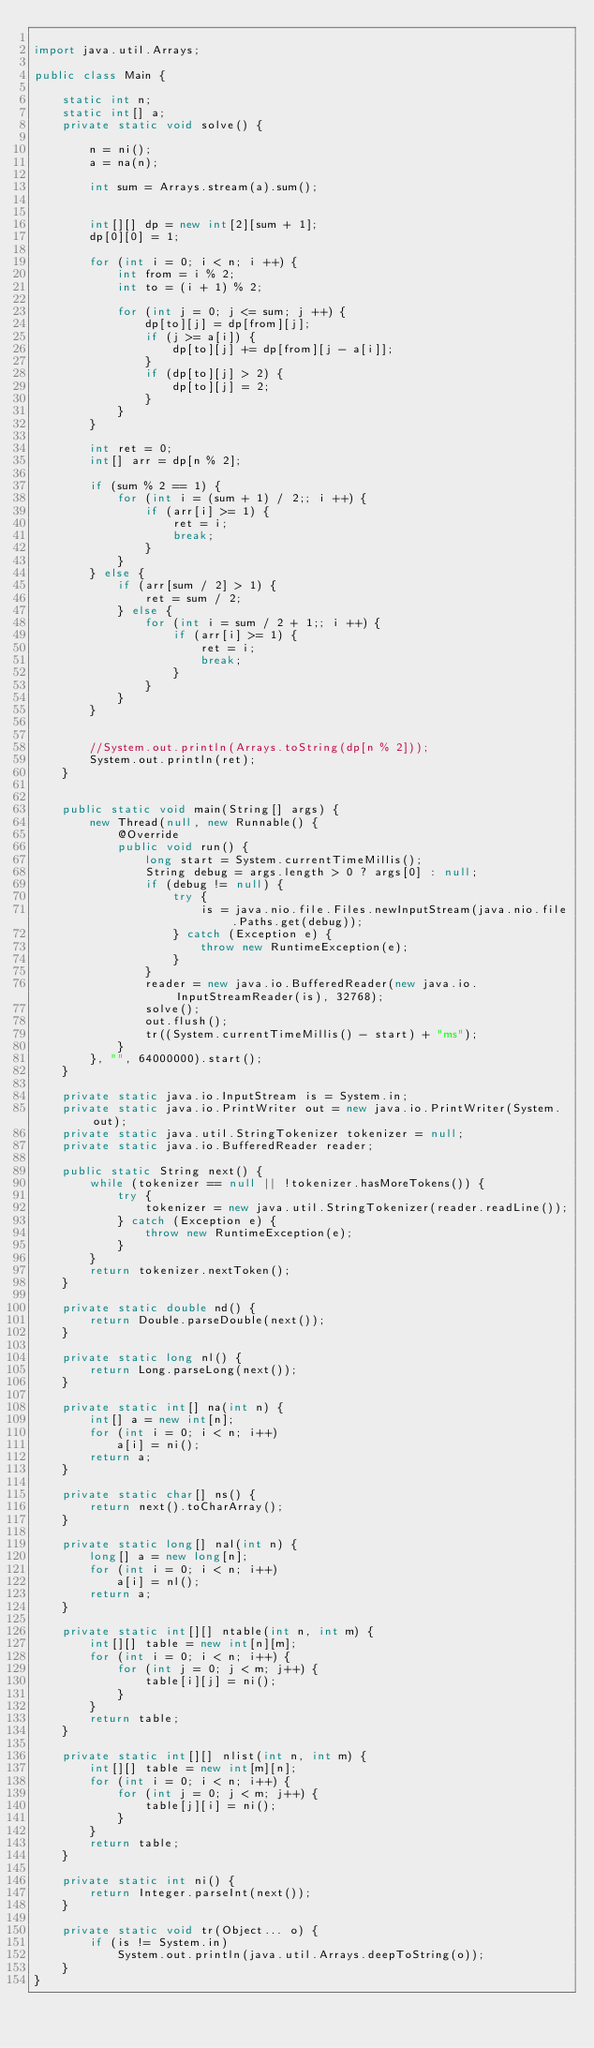Convert code to text. <code><loc_0><loc_0><loc_500><loc_500><_Java_>
import java.util.Arrays;

public class Main {

	static int n;
	static int[] a;
	private static void solve() {
		
		n = ni();
		a = na(n);

		int sum = Arrays.stream(a).sum();


		int[][] dp = new int[2][sum + 1];
		dp[0][0] = 1;

		for (int i = 0; i < n; i ++) {
			int from = i % 2;
			int to = (i + 1) % 2;
			
			for (int j = 0; j <= sum; j ++) {
				dp[to][j] = dp[from][j];
				if (j >= a[i]) {
					dp[to][j] += dp[from][j - a[i]];
				}
				if (dp[to][j] > 2) {
					dp[to][j] = 2;
				}
			}
		}
		
		int ret = 0;
		int[] arr = dp[n % 2];

		if (sum % 2 == 1) {
			for (int i = (sum + 1) / 2;; i ++) {
				if (arr[i] >= 1) {
					ret = i;
					break;
				}
			}
		} else {
			if (arr[sum / 2] > 1) {
				ret = sum / 2;
			} else {
				for (int i = sum / 2 + 1;; i ++) {
					if (arr[i] >= 1) {
						ret = i;
						break;
					}
				}
			}
		}
		
		
		//System.out.println(Arrays.toString(dp[n % 2]));
		System.out.println(ret);
	}
	

	public static void main(String[] args) {
		new Thread(null, new Runnable() {
			@Override
			public void run() {
				long start = System.currentTimeMillis();
				String debug = args.length > 0 ? args[0] : null;
				if (debug != null) {
					try {
						is = java.nio.file.Files.newInputStream(java.nio.file.Paths.get(debug));
					} catch (Exception e) {
						throw new RuntimeException(e);
					}
				}
				reader = new java.io.BufferedReader(new java.io.InputStreamReader(is), 32768);
				solve();
				out.flush();
				tr((System.currentTimeMillis() - start) + "ms");
			}
		}, "", 64000000).start();
	}

	private static java.io.InputStream is = System.in;
	private static java.io.PrintWriter out = new java.io.PrintWriter(System.out);
	private static java.util.StringTokenizer tokenizer = null;
	private static java.io.BufferedReader reader;

	public static String next() {
		while (tokenizer == null || !tokenizer.hasMoreTokens()) {
			try {
				tokenizer = new java.util.StringTokenizer(reader.readLine());
			} catch (Exception e) {
				throw new RuntimeException(e);
			}
		}
		return tokenizer.nextToken();
	}

	private static double nd() {
		return Double.parseDouble(next());
	}

	private static long nl() {
		return Long.parseLong(next());
	}

	private static int[] na(int n) {
		int[] a = new int[n];
		for (int i = 0; i < n; i++)
			a[i] = ni();
		return a;
	}

	private static char[] ns() {
		return next().toCharArray();
	}

	private static long[] nal(int n) {
		long[] a = new long[n];
		for (int i = 0; i < n; i++)
			a[i] = nl();
		return a;
	}

	private static int[][] ntable(int n, int m) {
		int[][] table = new int[n][m];
		for (int i = 0; i < n; i++) {
			for (int j = 0; j < m; j++) {
				table[i][j] = ni();
			}
		}
		return table;
	}

	private static int[][] nlist(int n, int m) {
		int[][] table = new int[m][n];
		for (int i = 0; i < n; i++) {
			for (int j = 0; j < m; j++) {
				table[j][i] = ni();
			}
		}
		return table;
	}

	private static int ni() {
		return Integer.parseInt(next());
	}

	private static void tr(Object... o) {
		if (is != System.in)
			System.out.println(java.util.Arrays.deepToString(o));
	}
}
</code> 